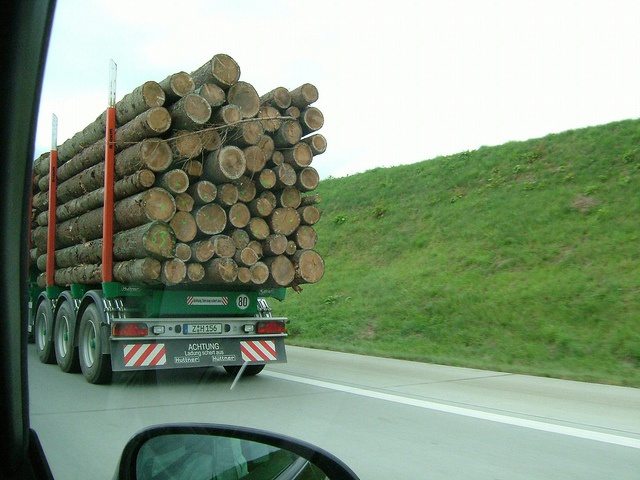Describe the objects in this image and their specific colors. I can see car in black, teal, and darkgreen tones and truck in black, teal, and darkgreen tones in this image. 